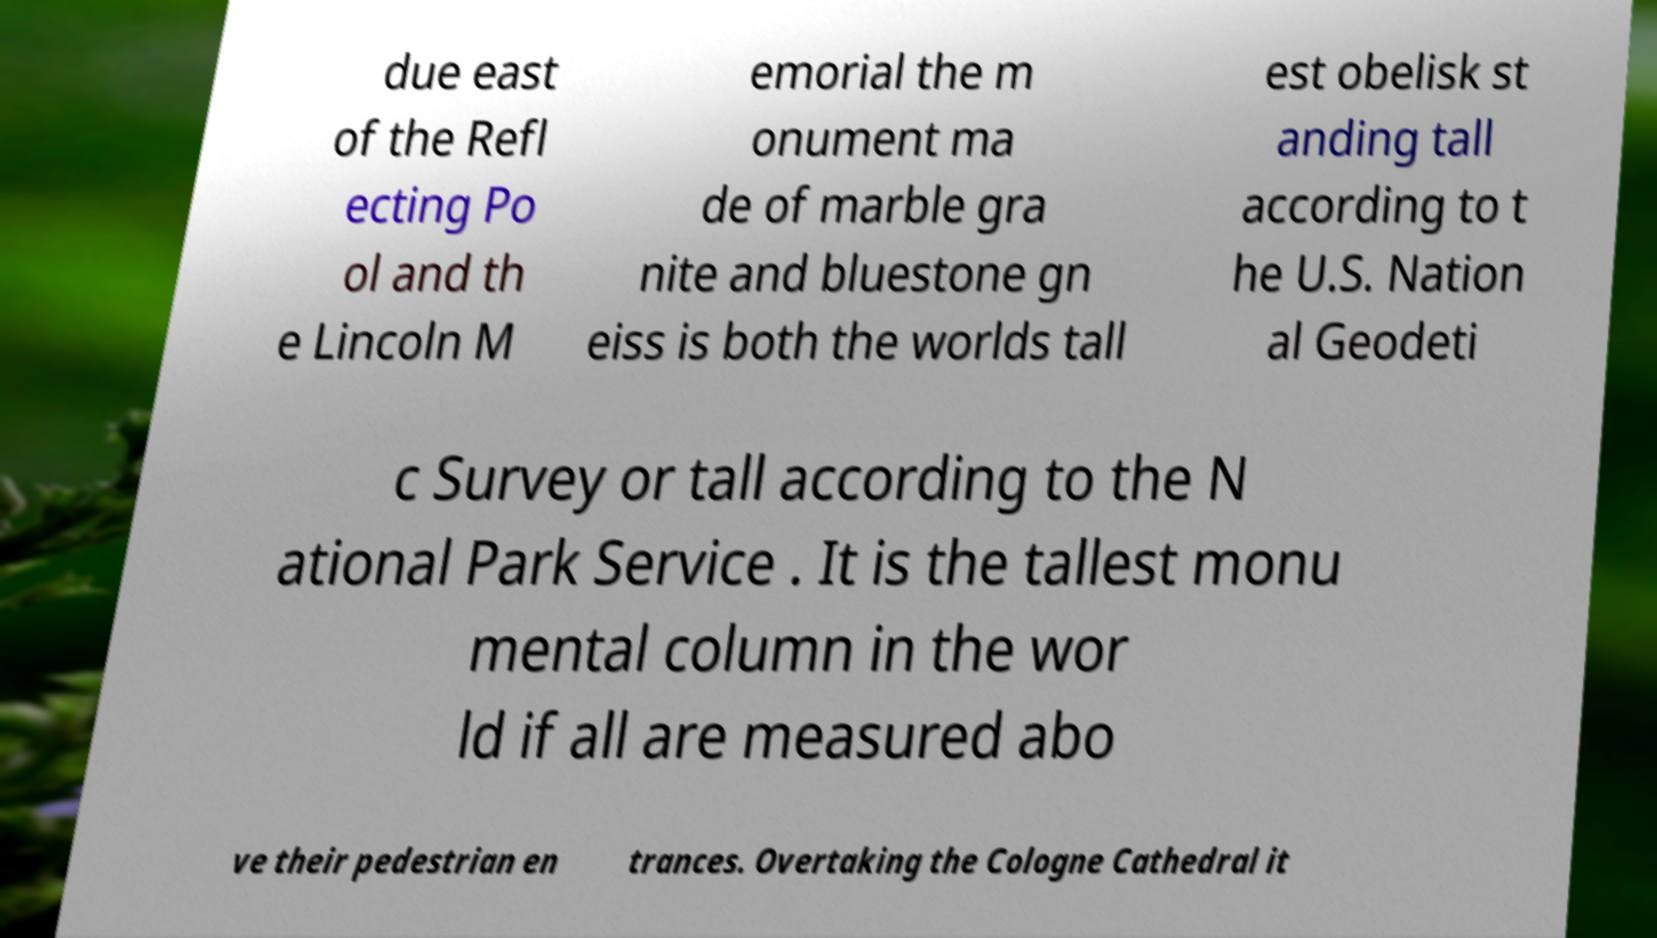What messages or text are displayed in this image? I need them in a readable, typed format. due east of the Refl ecting Po ol and th e Lincoln M emorial the m onument ma de of marble gra nite and bluestone gn eiss is both the worlds tall est obelisk st anding tall according to t he U.S. Nation al Geodeti c Survey or tall according to the N ational Park Service . It is the tallest monu mental column in the wor ld if all are measured abo ve their pedestrian en trances. Overtaking the Cologne Cathedral it 